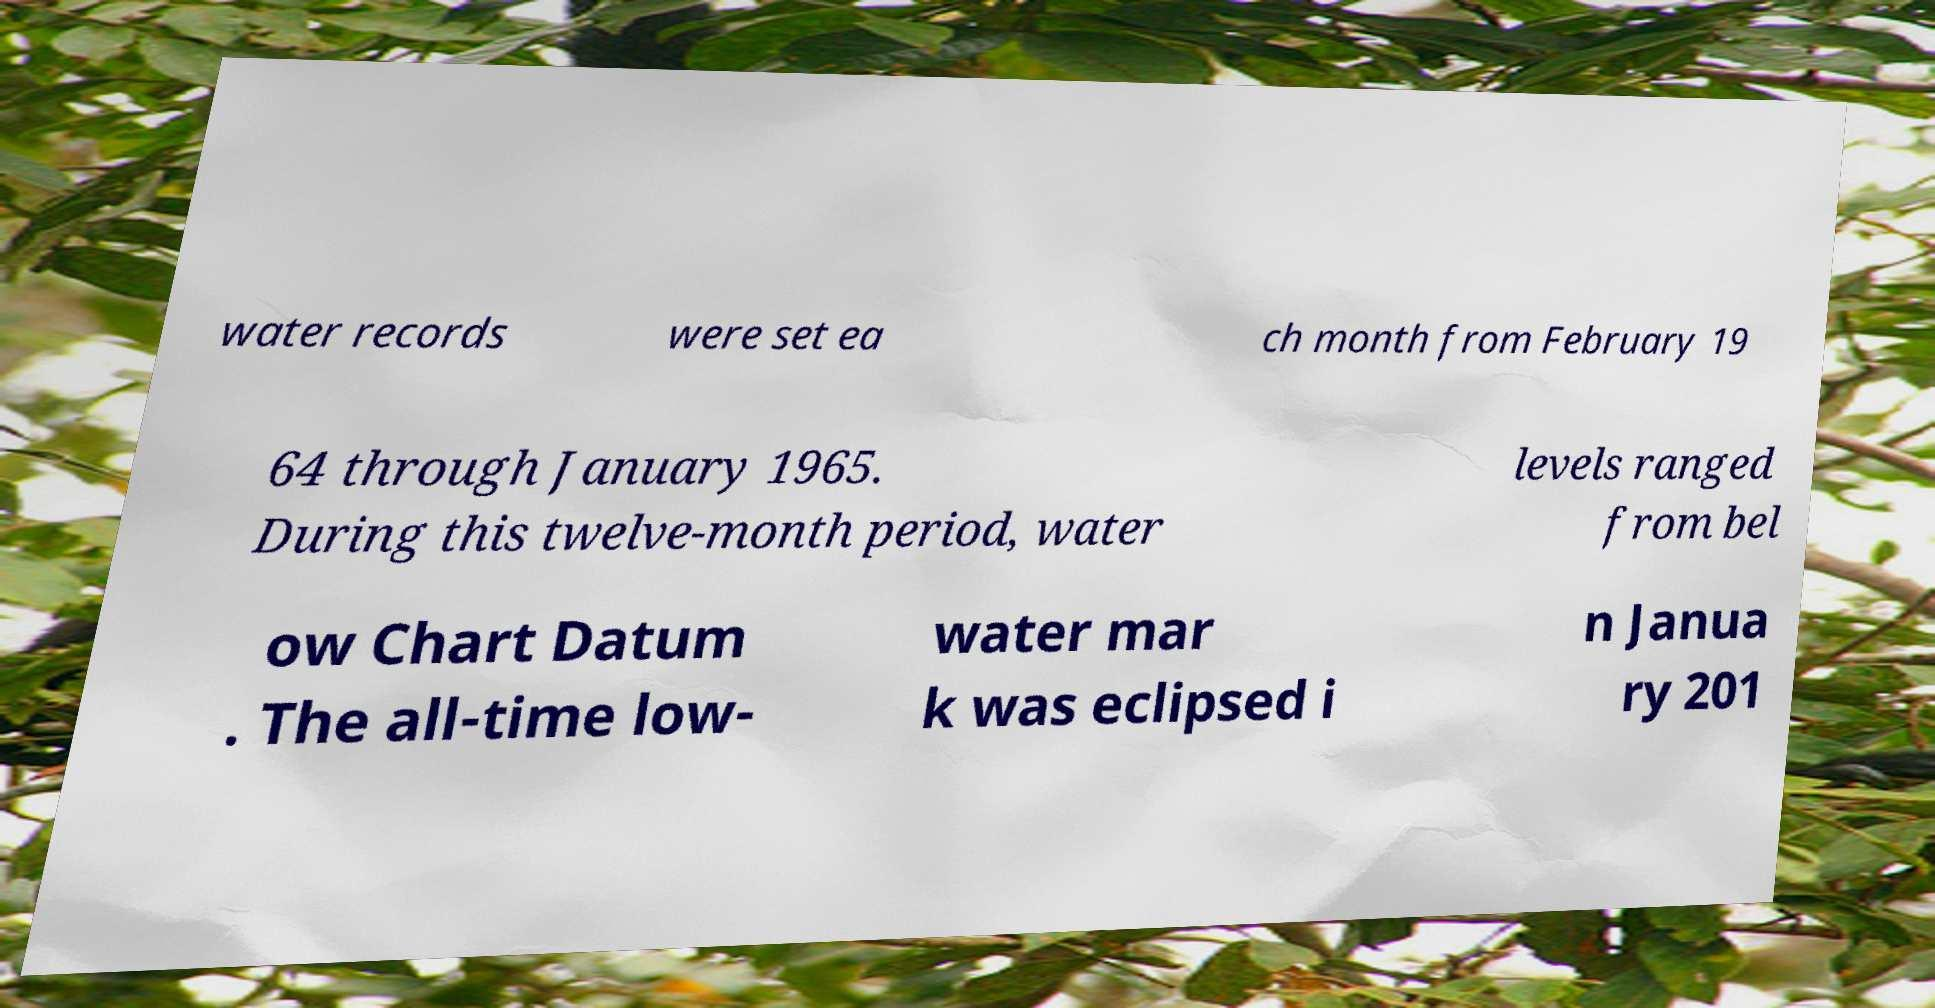What messages or text are displayed in this image? I need them in a readable, typed format. water records were set ea ch month from February 19 64 through January 1965. During this twelve-month period, water levels ranged from bel ow Chart Datum . The all-time low- water mar k was eclipsed i n Janua ry 201 